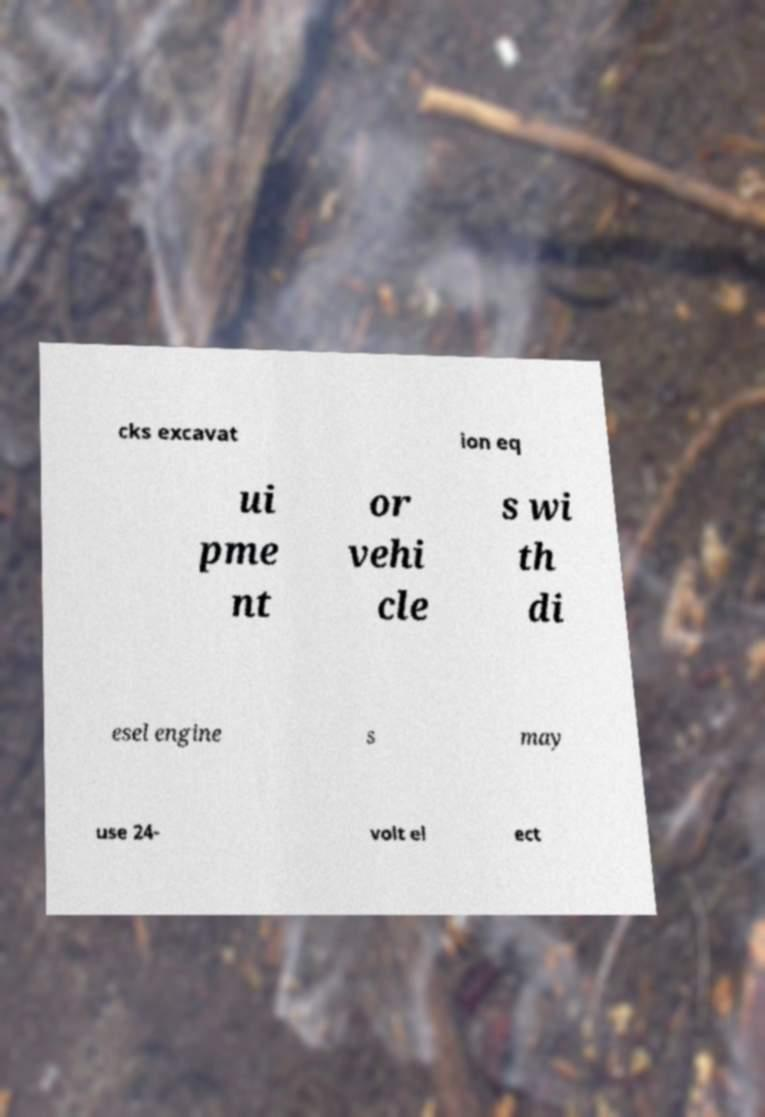Can you read and provide the text displayed in the image?This photo seems to have some interesting text. Can you extract and type it out for me? cks excavat ion eq ui pme nt or vehi cle s wi th di esel engine s may use 24- volt el ect 